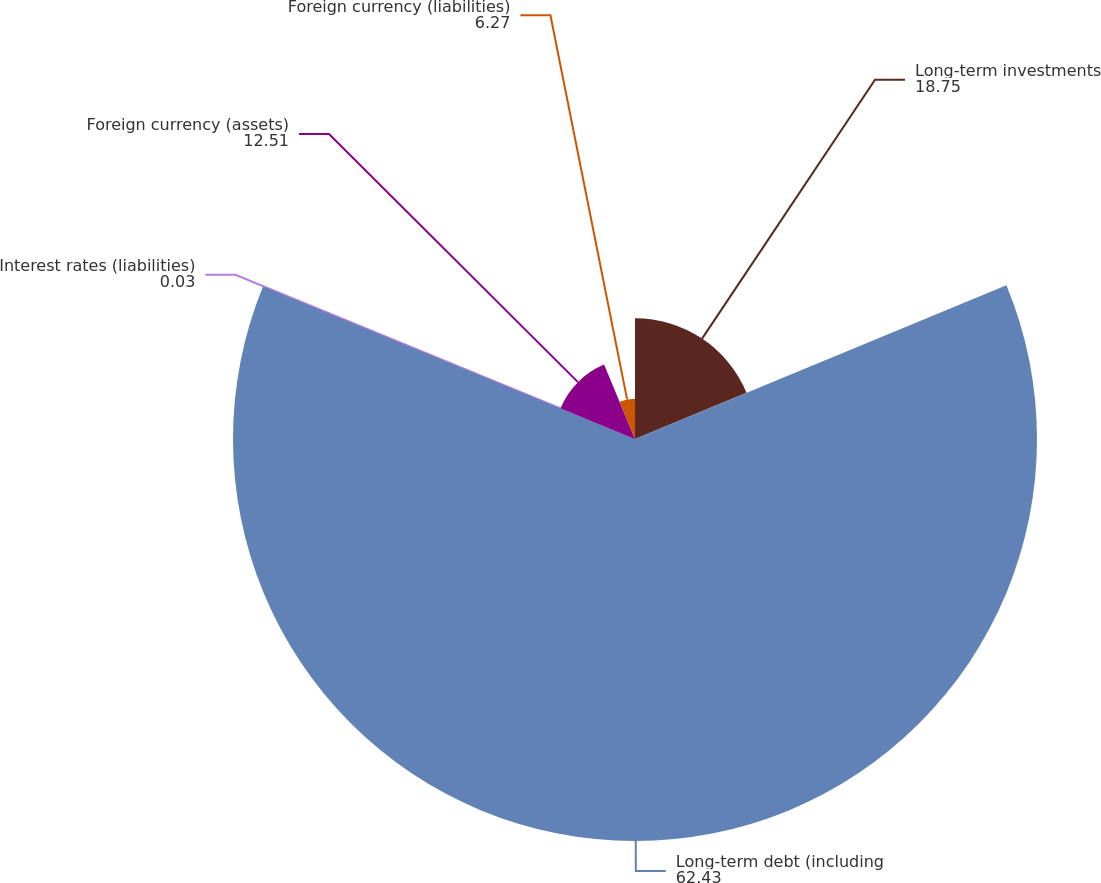<chart> <loc_0><loc_0><loc_500><loc_500><pie_chart><fcel>Long-term investments<fcel>Long-term debt (including<fcel>Interest rates (liabilities)<fcel>Foreign currency (assets)<fcel>Foreign currency (liabilities)<nl><fcel>18.75%<fcel>62.43%<fcel>0.03%<fcel>12.51%<fcel>6.27%<nl></chart> 